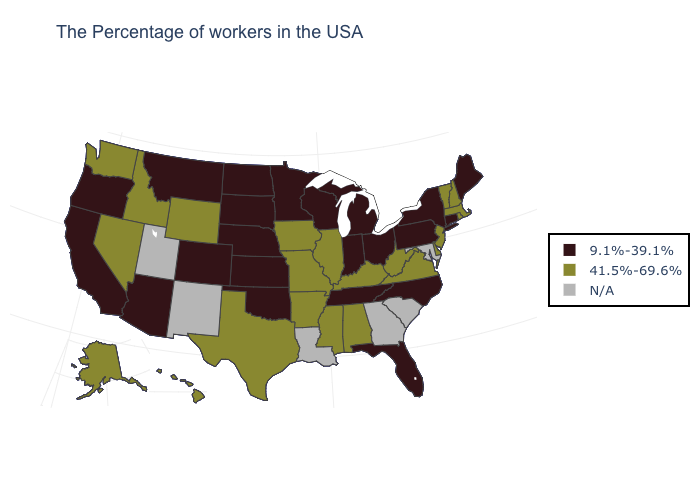What is the value of Oklahoma?
Quick response, please. 9.1%-39.1%. Does West Virginia have the highest value in the USA?
Be succinct. Yes. Is the legend a continuous bar?
Short answer required. No. What is the lowest value in states that border Florida?
Quick response, please. 41.5%-69.6%. What is the lowest value in states that border Wyoming?
Quick response, please. 9.1%-39.1%. What is the value of Ohio?
Short answer required. 9.1%-39.1%. Name the states that have a value in the range 41.5%-69.6%?
Write a very short answer. Massachusetts, Rhode Island, New Hampshire, Vermont, New Jersey, Delaware, Virginia, West Virginia, Kentucky, Alabama, Illinois, Mississippi, Missouri, Arkansas, Iowa, Texas, Wyoming, Idaho, Nevada, Washington, Alaska, Hawaii. What is the value of Rhode Island?
Answer briefly. 41.5%-69.6%. What is the highest value in the MidWest ?
Keep it brief. 41.5%-69.6%. Does Delaware have the lowest value in the USA?
Give a very brief answer. No. What is the value of New Mexico?
Quick response, please. N/A. Among the states that border Connecticut , does Rhode Island have the lowest value?
Concise answer only. No. Does Massachusetts have the highest value in the USA?
Quick response, please. Yes. What is the lowest value in the South?
Be succinct. 9.1%-39.1%. What is the value of Arkansas?
Answer briefly. 41.5%-69.6%. 